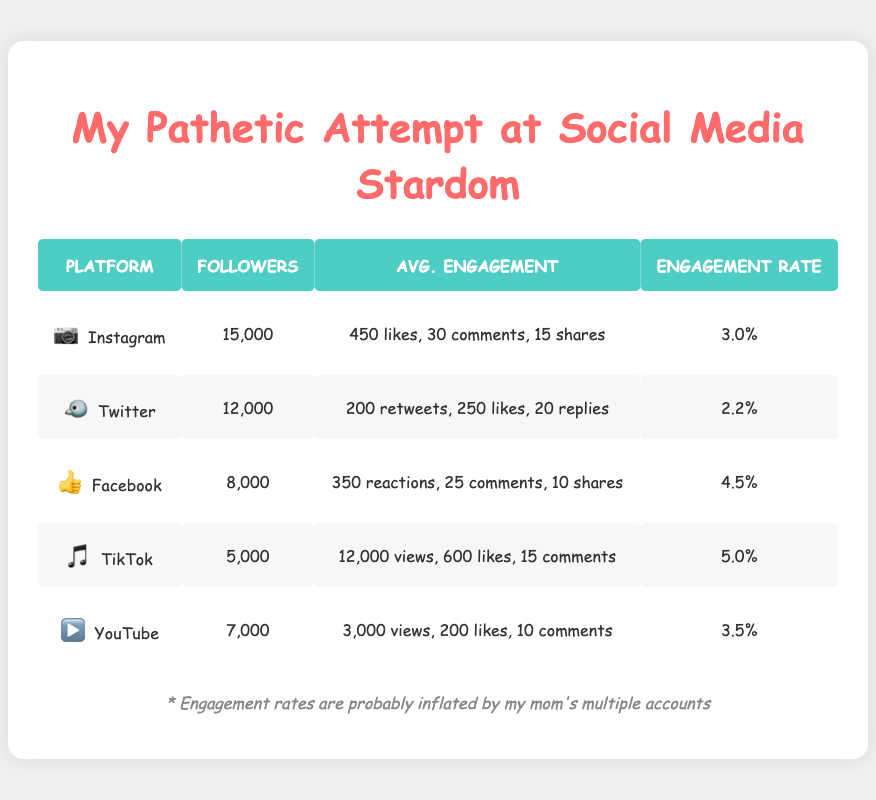What's the engagement rate for TikTok? Refer to the table under the TikTok row, the engagement rate is displayed as 5.0%
Answer: 5.0% Which platform has the highest average reactions? In the Facebook row, the average reactions are listed as 350, which is higher than any other platform's engagement metrics
Answer: Facebook What is the total number of followers across all platforms? Adding the followers from each platform: 15000 (Instagram) + 12000 (Twitter) + 8000 (Facebook) + 5000 (TikTok) + 7000 (YouTube) = 48000
Answer: 48000 Is the average comments on Instagram higher than on Facebook? The average comments are 30 on Instagram and 25 on Facebook; since 30 is higher than 25, the statement is true
Answer: Yes What is the average engagement rate for all platforms listed? To find the average engagement rate, sum the engagement rates: 3.0 + 2.2 + 4.5 + 5.0 + 3.5 = 18.2 and divide by the number of platforms (5): 18.2/5 = 3.64
Answer: 3.64 Which platform has the lowest engagement rate? Looking through the engagement rates in the table, Twitter has the lowest rate at 2.2%
Answer: Twitter If you combine the average likes from Instagram and TikTok, what do you get? Adding the average likes from Instagram (450) and TikTok (600) gives 450 + 600 = 1050
Answer: 1050 Is there a platform that has more than 10 shares on average? The average shares for Facebook is 10 and for Instagram, it's 15, so there are platforms above 10 shares on average
Answer: Yes What is the average number of views for the platforms that provide them? Only TikTok (12000 views) and YouTube (3000 views) provide view counts. Averaging these: (12000 + 3000) / 2 = 7500
Answer: 7500 